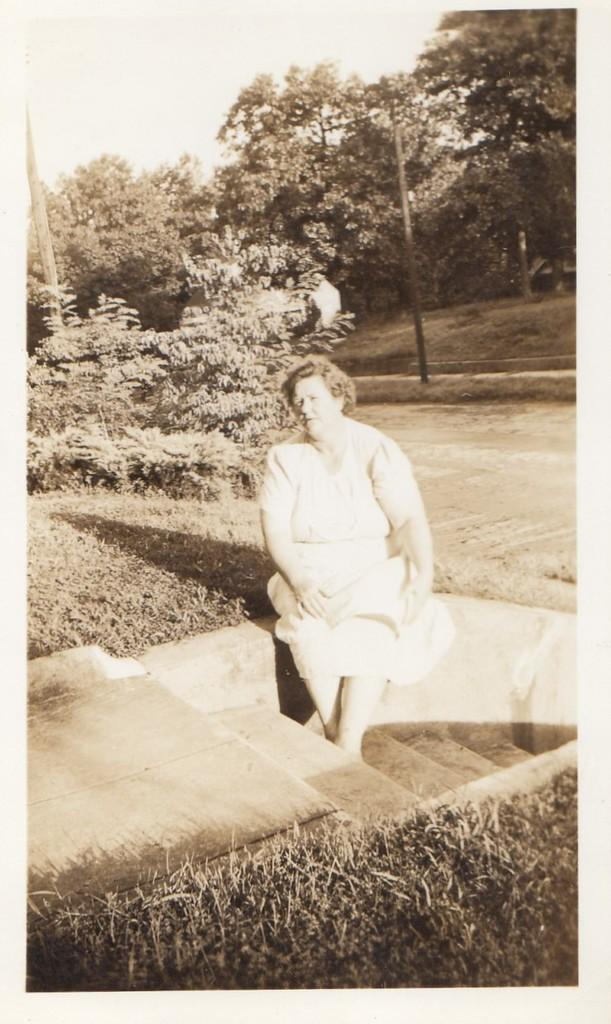Who is present in the image? There is a woman in the image. What is the woman wearing? The woman is wearing a white dress. What type of terrain is visible at the bottom of the image? There is grass at the bottom of the image. What architectural feature can be seen in the middle of the image? There are steps in the middle of the image. What part of the natural environment is visible at the top of the image? The sky is visible at the top of the image. What can be seen in the background of the image? There are trees in the background of the image. What type of finger food is being served for dinner in the image? There is no dinner or finger food present in the image. Can you tell me how many roses are in the woman's hair in the image? There is no rose or any indication of flowers in the woman's hair in the image. 